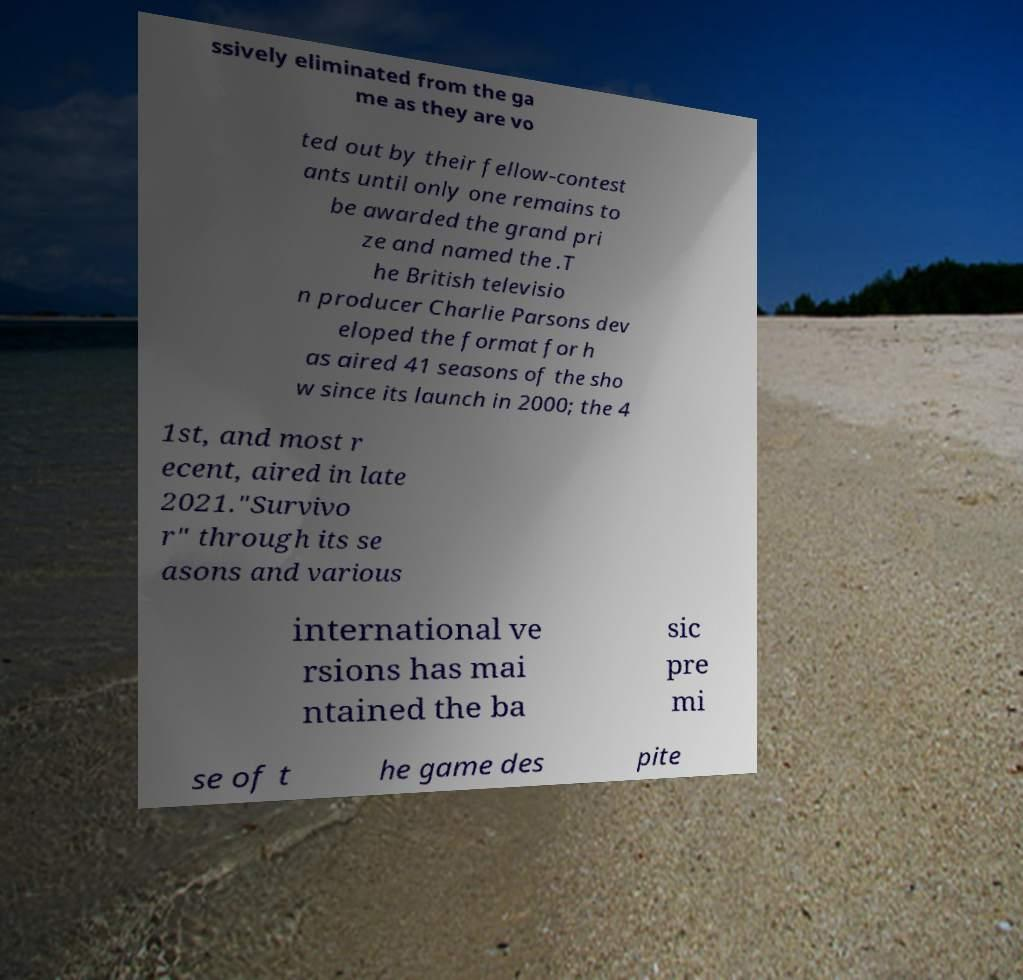Can you read and provide the text displayed in the image?This photo seems to have some interesting text. Can you extract and type it out for me? ssively eliminated from the ga me as they are vo ted out by their fellow-contest ants until only one remains to be awarded the grand pri ze and named the .T he British televisio n producer Charlie Parsons dev eloped the format for h as aired 41 seasons of the sho w since its launch in 2000; the 4 1st, and most r ecent, aired in late 2021."Survivo r" through its se asons and various international ve rsions has mai ntained the ba sic pre mi se of t he game des pite 